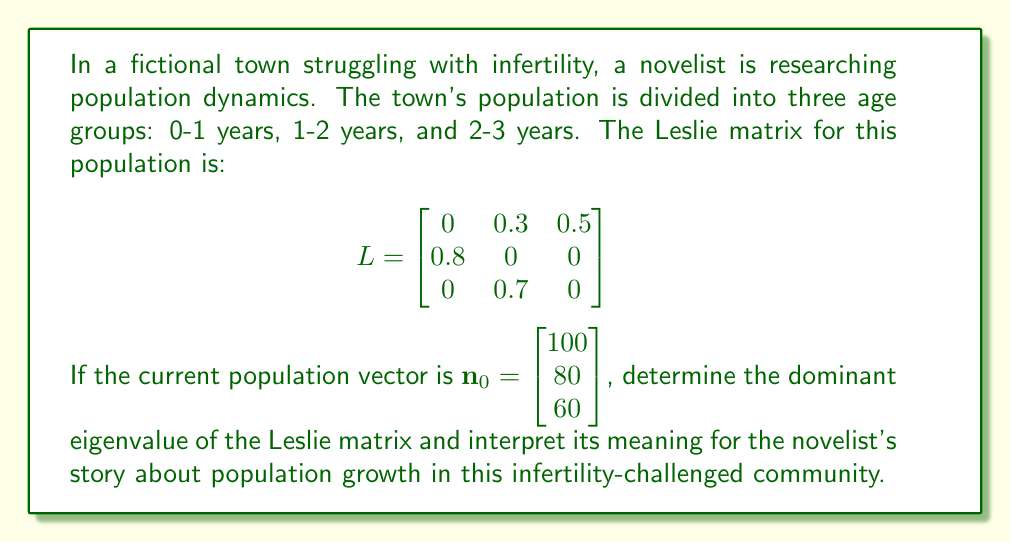What is the answer to this math problem? To solve this problem, we need to follow these steps:

1) First, we need to find the characteristic equation of the Leslie matrix:
   $$det(L - \lambda I) = 0$$
   
   $$\begin{vmatrix}
   -\lambda & 0.3 & 0.5 \\
   0.8 & -\lambda & 0 \\
   0 & 0.7 & -\lambda
   \end{vmatrix} = 0$$

2) Expanding this determinant:
   $$-\lambda^3 + 0.21\lambda + 0.28 = 0$$

3) This cubic equation can be solved numerically. The largest real root (dominant eigenvalue) is approximately 1.0296.

4) The dominant eigenvalue represents the long-term growth rate of the population. In this case:
   $$\lambda \approx 1.0296$$

5) This means that in each time step (year), the population is expected to grow by about 2.96%.

6) For the novelist's story, this implies that despite the town's struggle with infertility, the population is still growing, albeit slowly. This growth rate could be due to factors such as immigration or improved medical interventions helping some couples conceive.

7) Over time, if this growth rate remains constant, the population would increase exponentially:
   $$\mathbf{n}_t \approx 1.0296^t \cdot \mathbf{n}_0$$
   where $t$ is the number of years from the initial population.
Answer: $\lambda \approx 1.0296$, indicating a population growth rate of about 2.96% per year. 